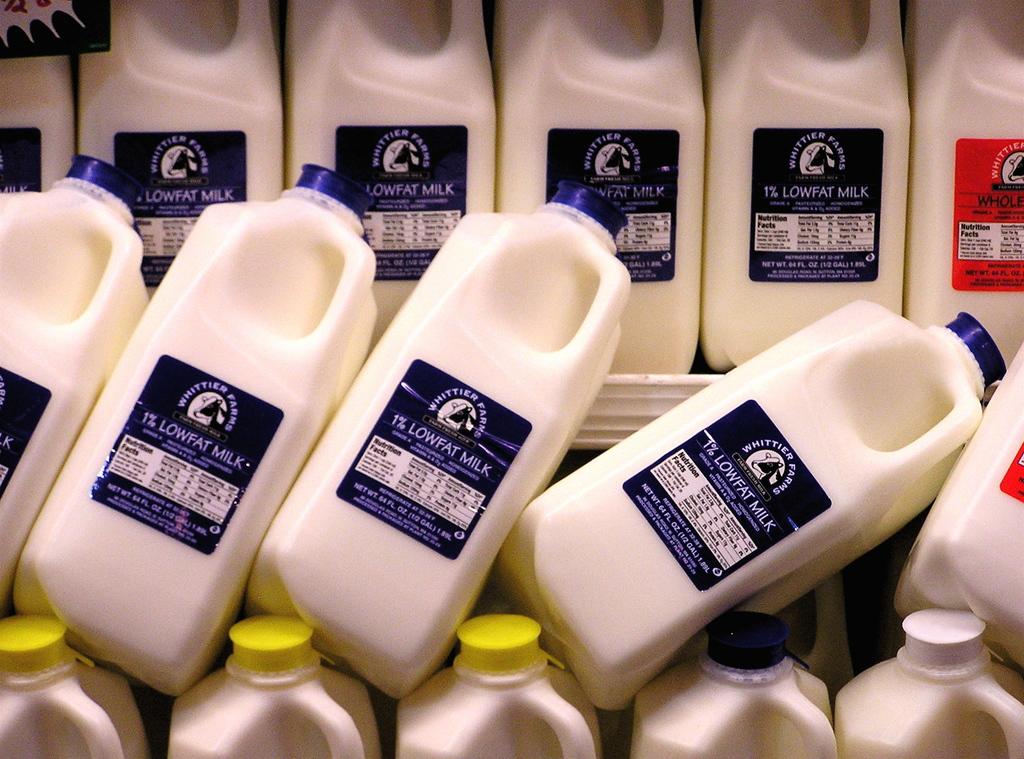What company is the manufacturer of this milk?
Provide a succinct answer. Whittier farms. What percent fat is this?
Your answer should be very brief. 1. 